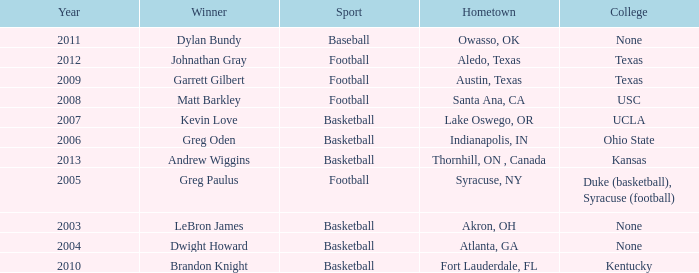What is Hometown, when Sport is "Basketball", and when Winner is "Dwight Howard"? Atlanta, GA. 